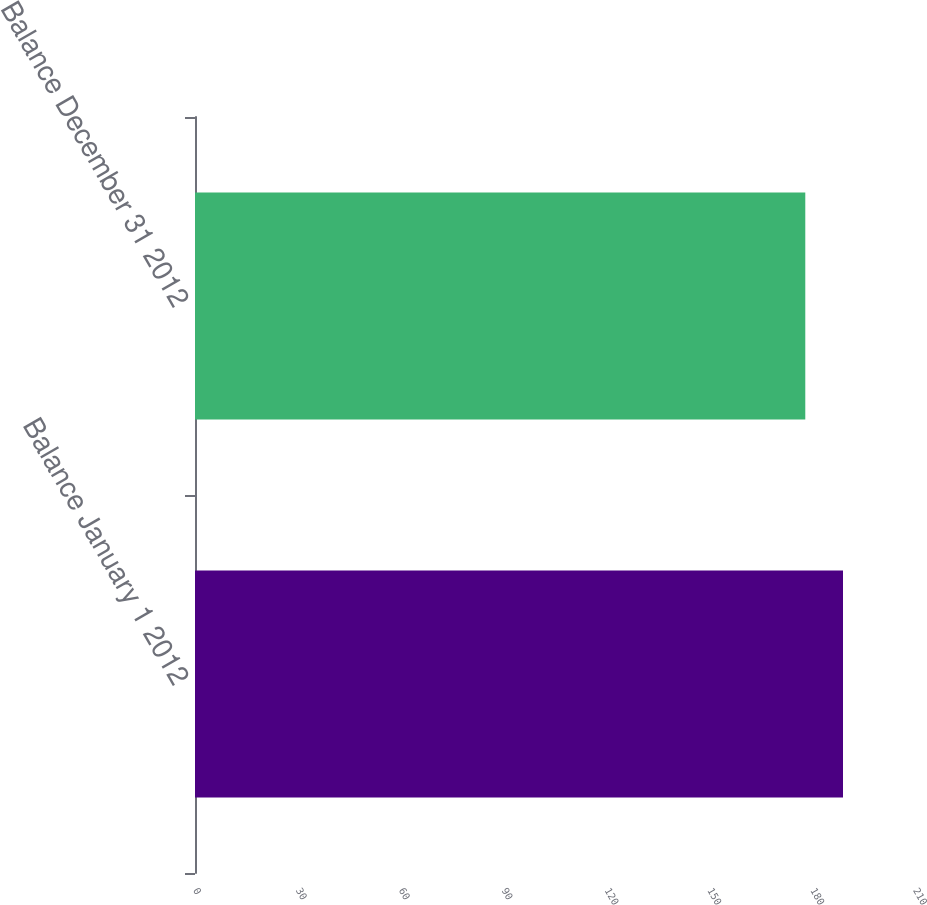<chart> <loc_0><loc_0><loc_500><loc_500><bar_chart><fcel>Balance January 1 2012<fcel>Balance December 31 2012<nl><fcel>189<fcel>178<nl></chart> 